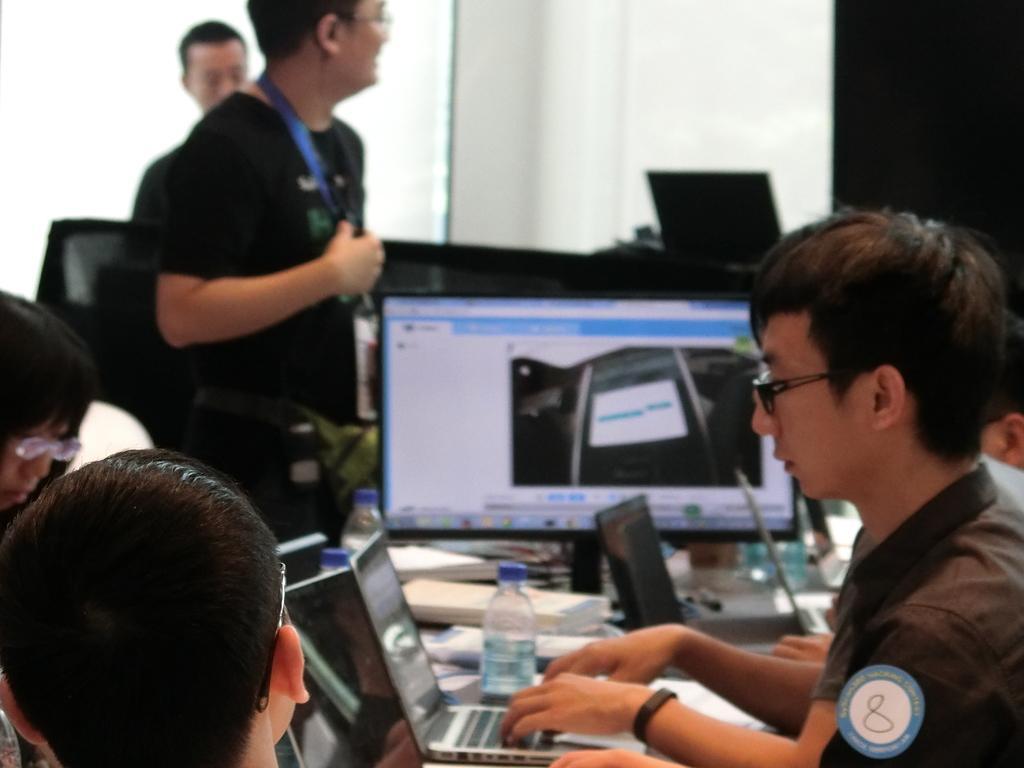How would you summarize this image in a sentence or two? In this image there are a few people. In the foreground there are people sitting. In front of them there is a table. On the table there are laptops, water bottles, books and a computer. Behind the computer there are two men standing. In the background there are chairs and a wall. 